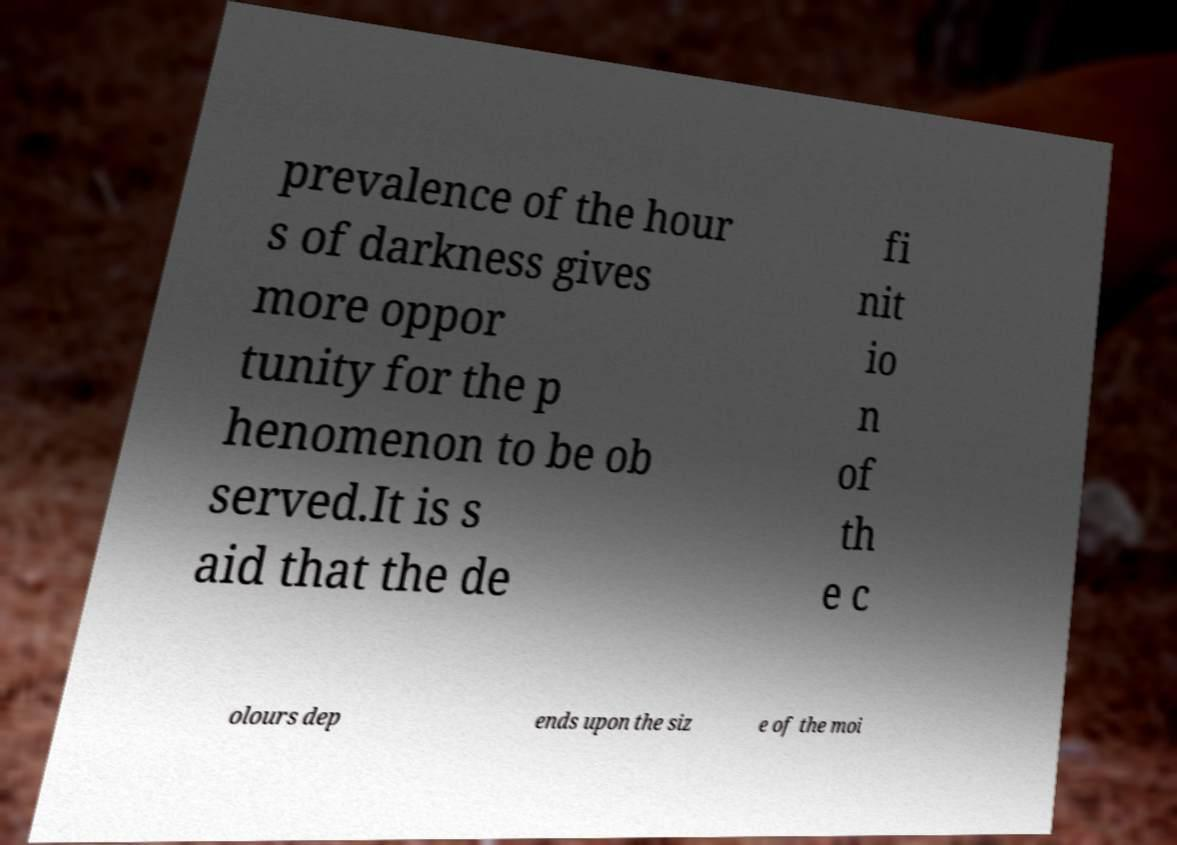Please read and relay the text visible in this image. What does it say? prevalence of the hour s of darkness gives more oppor tunity for the p henomenon to be ob served.It is s aid that the de fi nit io n of th e c olours dep ends upon the siz e of the moi 